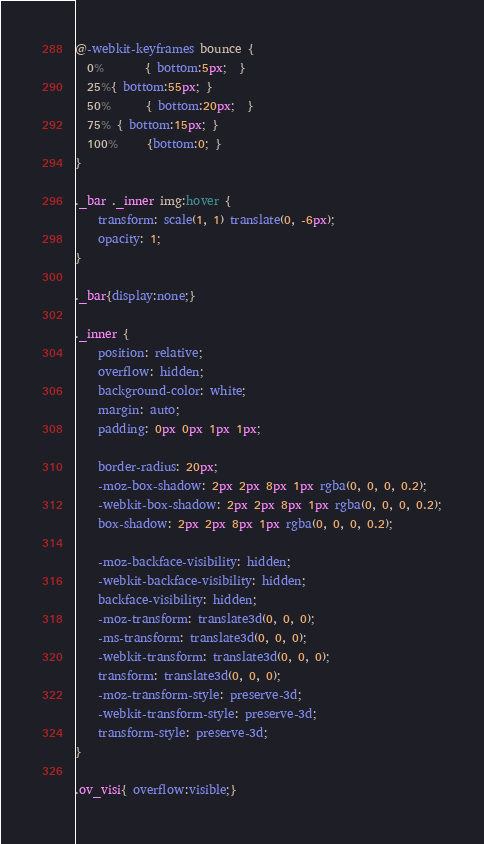<code> <loc_0><loc_0><loc_500><loc_500><_CSS_>
@-webkit-keyframes bounce {
  0%       { bottom:5px;  }
  25%{ bottom:55px; }
  50%      { bottom:20px;  }
  75% { bottom:15px; }
  100%     {bottom:0; }
}

._bar ._inner img:hover {
	transform: scale(1, 1) translate(0, -6px);
	opacity: 1;
}

._bar{display:none;}

._inner {
	position: relative;
	overflow: hidden;
	background-color: white;
	margin: auto;
	padding: 0px 0px 1px 1px;

	border-radius: 20px;
	-moz-box-shadow: 2px 2px 8px 1px rgba(0, 0, 0, 0.2);
	-webkit-box-shadow: 2px 2px 8px 1px rgba(0, 0, 0, 0.2);
	box-shadow: 2px 2px 8px 1px rgba(0, 0, 0, 0.2);

	-moz-backface-visibility: hidden;
	-webkit-backface-visibility: hidden;
	backface-visibility: hidden;
	-moz-transform: translate3d(0, 0, 0);
	-ms-transform: translate3d(0, 0, 0);
	-webkit-transform: translate3d(0, 0, 0);
	transform: translate3d(0, 0, 0);
	-moz-transform-style: preserve-3d;
	-webkit-transform-style: preserve-3d;
	transform-style: preserve-3d;
}

.ov_visi{ overflow:visible;}
</code> 